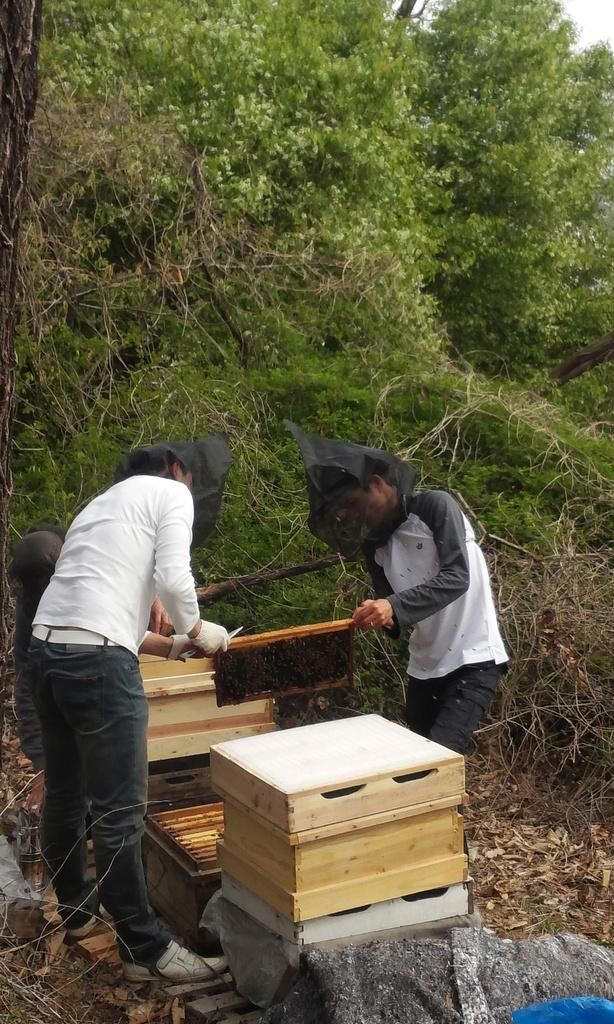How many people are in the image? There are two people in the image. What are the people doing in the image? The people are standing and holding a wooden frame. What is inside the wooden frame? The wooden frame contains a honeycomb. What is at the bottom of the wooden frame? There are wooden blocks at the bottom. What can be seen in the background of the image? There are trees and the sky visible in the background of the image. What color is the wax on the person's eye in the image? There is no wax or person's eye visible in the image; it features two people holding a wooden frame with a honeycomb. 